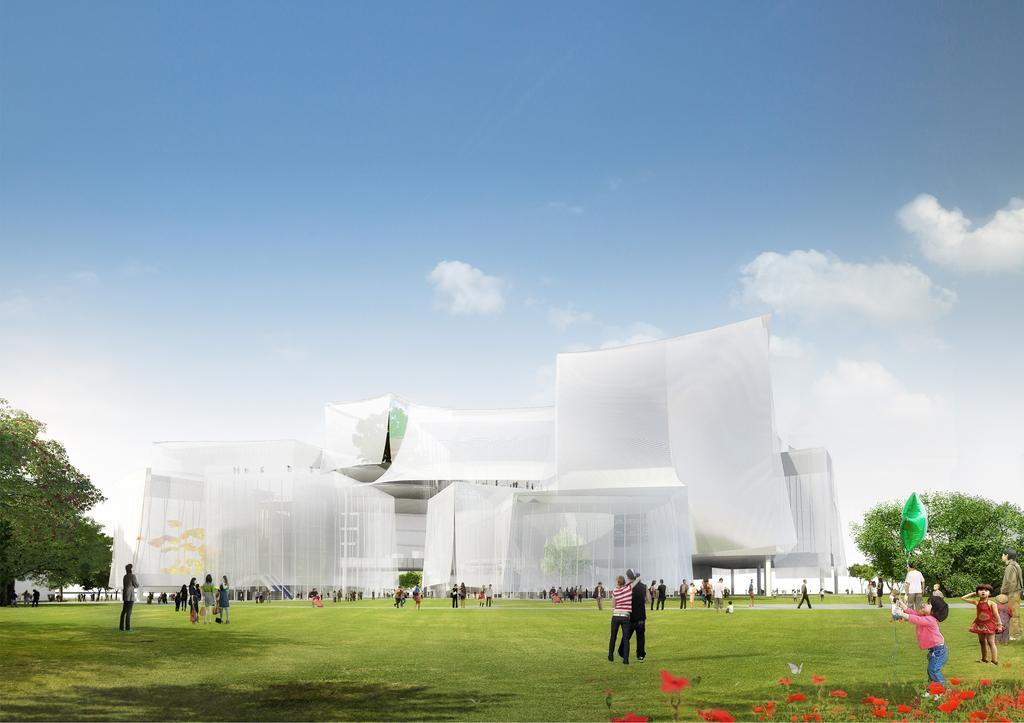In one or two sentences, can you explain what this image depicts? At the bottom of the image, we can see a building covered with clothes. Here we can see trees, few people. Few are standing and walking. On the right side of the image, we can see green color balloon. Here we can see few flowers. Background there is a sky. 